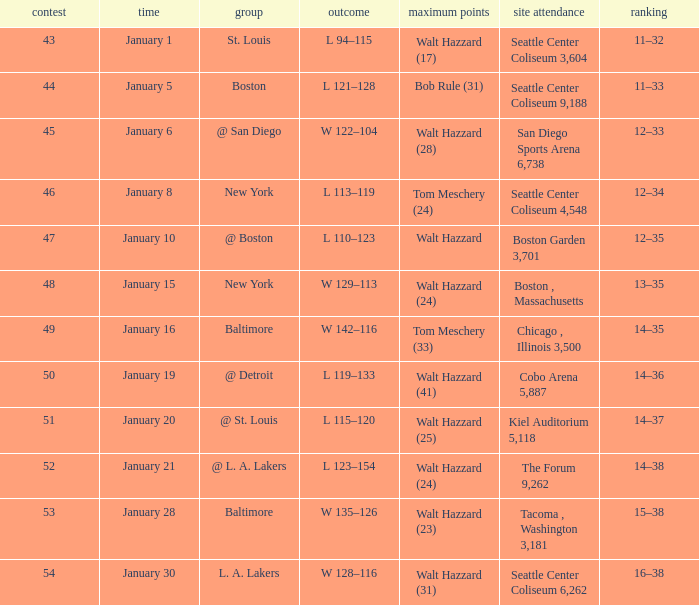What is the record for the St. Louis team? 11–32. 